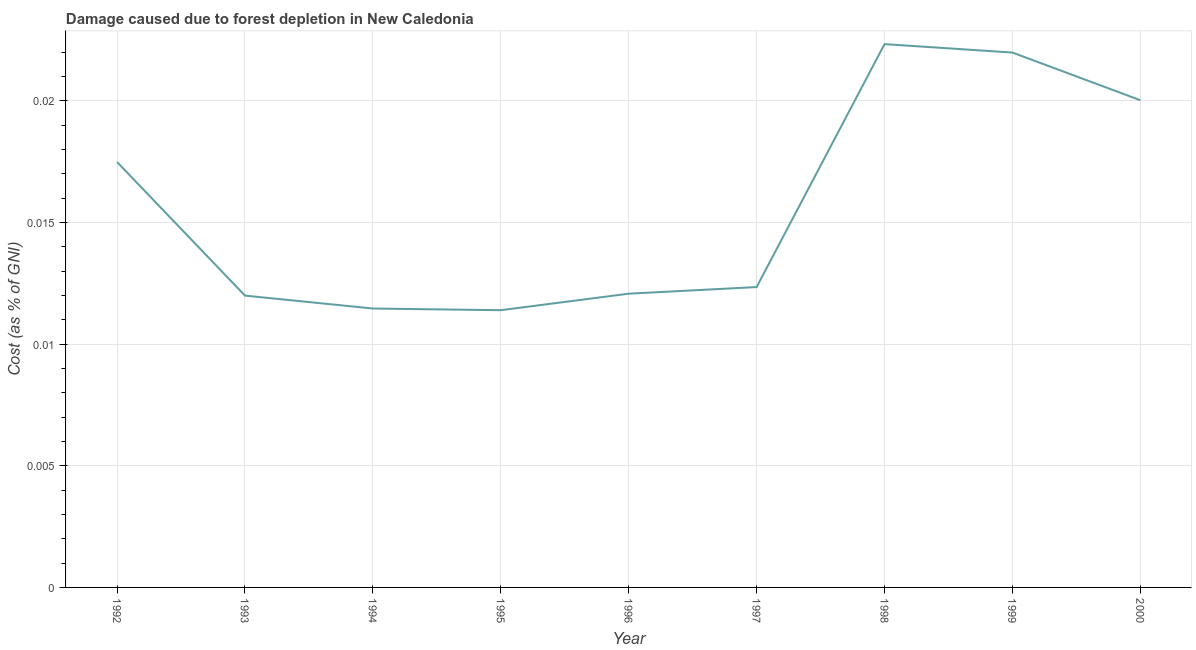What is the damage caused due to forest depletion in 2000?
Your answer should be very brief. 0.02. Across all years, what is the maximum damage caused due to forest depletion?
Your response must be concise. 0.02. Across all years, what is the minimum damage caused due to forest depletion?
Give a very brief answer. 0.01. In which year was the damage caused due to forest depletion maximum?
Give a very brief answer. 1998. What is the sum of the damage caused due to forest depletion?
Provide a short and direct response. 0.14. What is the difference between the damage caused due to forest depletion in 1995 and 1996?
Make the answer very short. -0. What is the average damage caused due to forest depletion per year?
Offer a terse response. 0.02. What is the median damage caused due to forest depletion?
Give a very brief answer. 0.01. In how many years, is the damage caused due to forest depletion greater than 0.021 %?
Offer a terse response. 2. Do a majority of the years between 1998 and 1993 (inclusive) have damage caused due to forest depletion greater than 0.021 %?
Make the answer very short. Yes. What is the ratio of the damage caused due to forest depletion in 1994 to that in 1999?
Your answer should be compact. 0.52. What is the difference between the highest and the second highest damage caused due to forest depletion?
Offer a very short reply. 0. What is the difference between the highest and the lowest damage caused due to forest depletion?
Offer a terse response. 0.01. In how many years, is the damage caused due to forest depletion greater than the average damage caused due to forest depletion taken over all years?
Ensure brevity in your answer.  4. Does the damage caused due to forest depletion monotonically increase over the years?
Make the answer very short. No. How many lines are there?
Keep it short and to the point. 1. How many years are there in the graph?
Provide a short and direct response. 9. What is the difference between two consecutive major ticks on the Y-axis?
Keep it short and to the point. 0.01. Does the graph contain any zero values?
Make the answer very short. No. What is the title of the graph?
Offer a terse response. Damage caused due to forest depletion in New Caledonia. What is the label or title of the X-axis?
Your response must be concise. Year. What is the label or title of the Y-axis?
Your answer should be very brief. Cost (as % of GNI). What is the Cost (as % of GNI) in 1992?
Provide a short and direct response. 0.02. What is the Cost (as % of GNI) in 1993?
Provide a succinct answer. 0.01. What is the Cost (as % of GNI) in 1994?
Make the answer very short. 0.01. What is the Cost (as % of GNI) of 1995?
Offer a very short reply. 0.01. What is the Cost (as % of GNI) of 1996?
Make the answer very short. 0.01. What is the Cost (as % of GNI) in 1997?
Offer a terse response. 0.01. What is the Cost (as % of GNI) in 1998?
Keep it short and to the point. 0.02. What is the Cost (as % of GNI) of 1999?
Offer a terse response. 0.02. What is the Cost (as % of GNI) of 2000?
Give a very brief answer. 0.02. What is the difference between the Cost (as % of GNI) in 1992 and 1993?
Make the answer very short. 0.01. What is the difference between the Cost (as % of GNI) in 1992 and 1994?
Ensure brevity in your answer.  0.01. What is the difference between the Cost (as % of GNI) in 1992 and 1995?
Your response must be concise. 0.01. What is the difference between the Cost (as % of GNI) in 1992 and 1996?
Offer a terse response. 0.01. What is the difference between the Cost (as % of GNI) in 1992 and 1997?
Your answer should be compact. 0.01. What is the difference between the Cost (as % of GNI) in 1992 and 1998?
Give a very brief answer. -0. What is the difference between the Cost (as % of GNI) in 1992 and 1999?
Give a very brief answer. -0. What is the difference between the Cost (as % of GNI) in 1992 and 2000?
Provide a succinct answer. -0. What is the difference between the Cost (as % of GNI) in 1993 and 1994?
Provide a short and direct response. 0. What is the difference between the Cost (as % of GNI) in 1993 and 1995?
Ensure brevity in your answer.  0. What is the difference between the Cost (as % of GNI) in 1993 and 1996?
Your answer should be compact. -8e-5. What is the difference between the Cost (as % of GNI) in 1993 and 1997?
Ensure brevity in your answer.  -0. What is the difference between the Cost (as % of GNI) in 1993 and 1998?
Offer a very short reply. -0.01. What is the difference between the Cost (as % of GNI) in 1993 and 1999?
Your answer should be very brief. -0.01. What is the difference between the Cost (as % of GNI) in 1993 and 2000?
Offer a terse response. -0.01. What is the difference between the Cost (as % of GNI) in 1994 and 1995?
Offer a terse response. 7e-5. What is the difference between the Cost (as % of GNI) in 1994 and 1996?
Offer a terse response. -0. What is the difference between the Cost (as % of GNI) in 1994 and 1997?
Provide a short and direct response. -0. What is the difference between the Cost (as % of GNI) in 1994 and 1998?
Your answer should be very brief. -0.01. What is the difference between the Cost (as % of GNI) in 1994 and 1999?
Ensure brevity in your answer.  -0.01. What is the difference between the Cost (as % of GNI) in 1994 and 2000?
Your answer should be very brief. -0.01. What is the difference between the Cost (as % of GNI) in 1995 and 1996?
Your answer should be compact. -0. What is the difference between the Cost (as % of GNI) in 1995 and 1997?
Provide a succinct answer. -0. What is the difference between the Cost (as % of GNI) in 1995 and 1998?
Provide a short and direct response. -0.01. What is the difference between the Cost (as % of GNI) in 1995 and 1999?
Your answer should be very brief. -0.01. What is the difference between the Cost (as % of GNI) in 1995 and 2000?
Provide a short and direct response. -0.01. What is the difference between the Cost (as % of GNI) in 1996 and 1997?
Make the answer very short. -0. What is the difference between the Cost (as % of GNI) in 1996 and 1998?
Offer a terse response. -0.01. What is the difference between the Cost (as % of GNI) in 1996 and 1999?
Provide a succinct answer. -0.01. What is the difference between the Cost (as % of GNI) in 1996 and 2000?
Your answer should be compact. -0.01. What is the difference between the Cost (as % of GNI) in 1997 and 1998?
Give a very brief answer. -0.01. What is the difference between the Cost (as % of GNI) in 1997 and 1999?
Provide a short and direct response. -0.01. What is the difference between the Cost (as % of GNI) in 1997 and 2000?
Give a very brief answer. -0.01. What is the difference between the Cost (as % of GNI) in 1998 and 1999?
Keep it short and to the point. 0. What is the difference between the Cost (as % of GNI) in 1998 and 2000?
Provide a succinct answer. 0. What is the difference between the Cost (as % of GNI) in 1999 and 2000?
Make the answer very short. 0. What is the ratio of the Cost (as % of GNI) in 1992 to that in 1993?
Your response must be concise. 1.46. What is the ratio of the Cost (as % of GNI) in 1992 to that in 1994?
Your answer should be very brief. 1.52. What is the ratio of the Cost (as % of GNI) in 1992 to that in 1995?
Keep it short and to the point. 1.53. What is the ratio of the Cost (as % of GNI) in 1992 to that in 1996?
Offer a very short reply. 1.45. What is the ratio of the Cost (as % of GNI) in 1992 to that in 1997?
Give a very brief answer. 1.42. What is the ratio of the Cost (as % of GNI) in 1992 to that in 1998?
Make the answer very short. 0.78. What is the ratio of the Cost (as % of GNI) in 1992 to that in 1999?
Your answer should be compact. 0.8. What is the ratio of the Cost (as % of GNI) in 1992 to that in 2000?
Your answer should be compact. 0.87. What is the ratio of the Cost (as % of GNI) in 1993 to that in 1994?
Your response must be concise. 1.05. What is the ratio of the Cost (as % of GNI) in 1993 to that in 1995?
Ensure brevity in your answer.  1.05. What is the ratio of the Cost (as % of GNI) in 1993 to that in 1996?
Your answer should be compact. 0.99. What is the ratio of the Cost (as % of GNI) in 1993 to that in 1997?
Keep it short and to the point. 0.97. What is the ratio of the Cost (as % of GNI) in 1993 to that in 1998?
Give a very brief answer. 0.54. What is the ratio of the Cost (as % of GNI) in 1993 to that in 1999?
Make the answer very short. 0.55. What is the ratio of the Cost (as % of GNI) in 1993 to that in 2000?
Your answer should be very brief. 0.6. What is the ratio of the Cost (as % of GNI) in 1994 to that in 1996?
Offer a very short reply. 0.95. What is the ratio of the Cost (as % of GNI) in 1994 to that in 1997?
Give a very brief answer. 0.93. What is the ratio of the Cost (as % of GNI) in 1994 to that in 1998?
Your answer should be compact. 0.51. What is the ratio of the Cost (as % of GNI) in 1994 to that in 1999?
Your answer should be compact. 0.52. What is the ratio of the Cost (as % of GNI) in 1994 to that in 2000?
Keep it short and to the point. 0.57. What is the ratio of the Cost (as % of GNI) in 1995 to that in 1996?
Offer a terse response. 0.94. What is the ratio of the Cost (as % of GNI) in 1995 to that in 1997?
Offer a very short reply. 0.92. What is the ratio of the Cost (as % of GNI) in 1995 to that in 1998?
Your answer should be very brief. 0.51. What is the ratio of the Cost (as % of GNI) in 1995 to that in 1999?
Ensure brevity in your answer.  0.52. What is the ratio of the Cost (as % of GNI) in 1995 to that in 2000?
Your answer should be compact. 0.57. What is the ratio of the Cost (as % of GNI) in 1996 to that in 1998?
Your response must be concise. 0.54. What is the ratio of the Cost (as % of GNI) in 1996 to that in 1999?
Ensure brevity in your answer.  0.55. What is the ratio of the Cost (as % of GNI) in 1996 to that in 2000?
Offer a terse response. 0.6. What is the ratio of the Cost (as % of GNI) in 1997 to that in 1998?
Provide a short and direct response. 0.55. What is the ratio of the Cost (as % of GNI) in 1997 to that in 1999?
Offer a terse response. 0.56. What is the ratio of the Cost (as % of GNI) in 1997 to that in 2000?
Keep it short and to the point. 0.62. What is the ratio of the Cost (as % of GNI) in 1998 to that in 2000?
Your answer should be very brief. 1.11. What is the ratio of the Cost (as % of GNI) in 1999 to that in 2000?
Offer a very short reply. 1.1. 